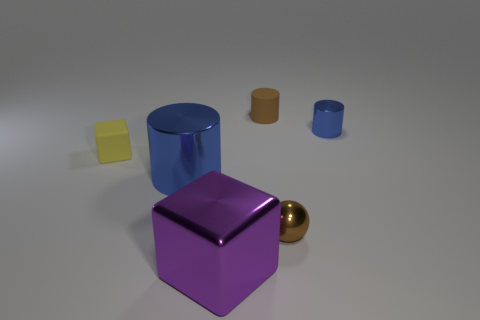There is a blue thing that is the same size as the yellow matte object; what is its shape? cylinder 